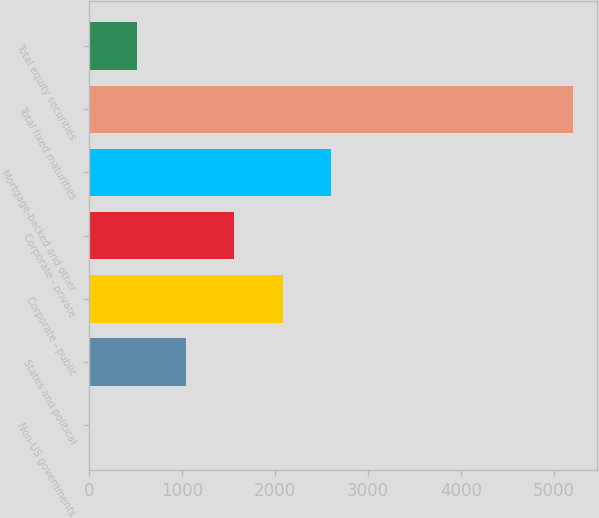Convert chart. <chart><loc_0><loc_0><loc_500><loc_500><bar_chart><fcel>Non-US governments<fcel>States and political<fcel>Corporate - public<fcel>Corporate - private<fcel>Mortgage-backed and other<fcel>Total fixed maturities<fcel>Total equity securities<nl><fcel>3.1<fcel>1042.94<fcel>2082.78<fcel>1562.86<fcel>2602.7<fcel>5202.3<fcel>523.02<nl></chart> 